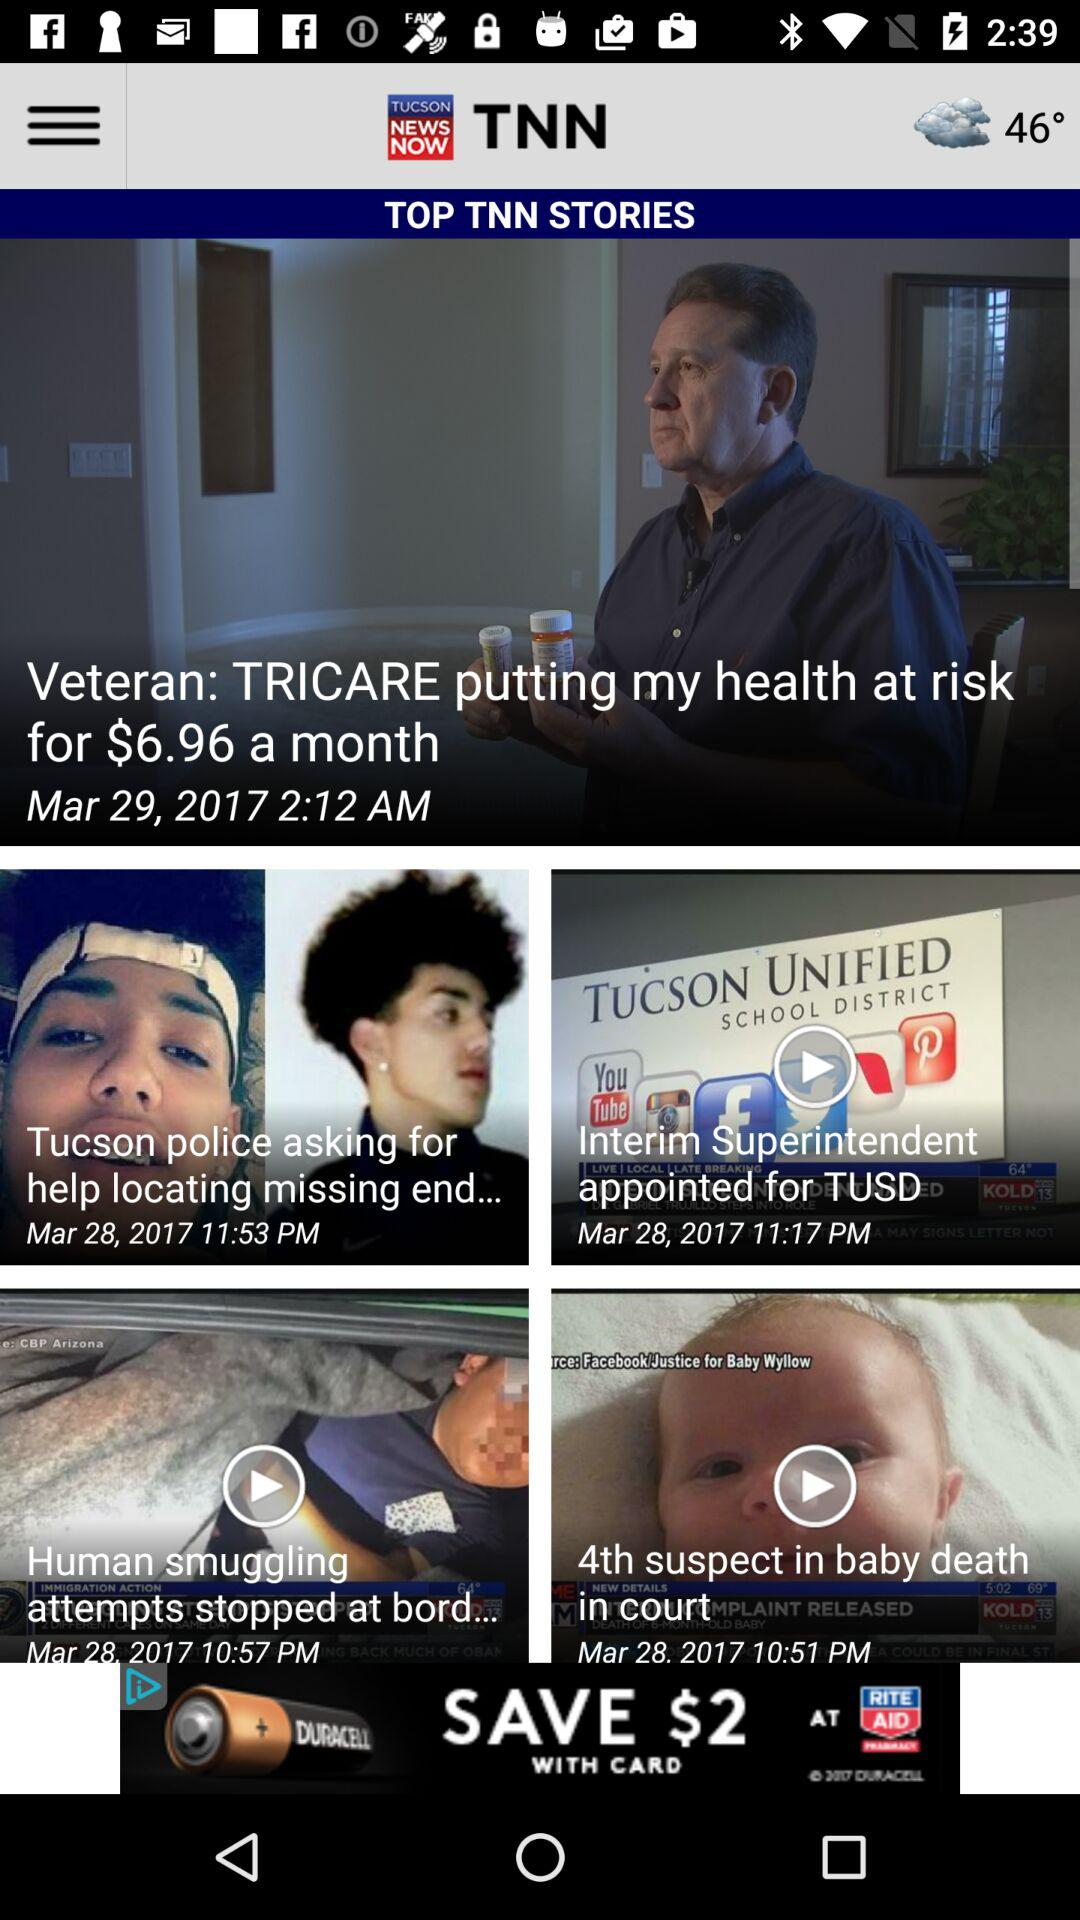On what date was the "Veteran" story posted? The "Veteran" story was posted on March 29, 2017. 